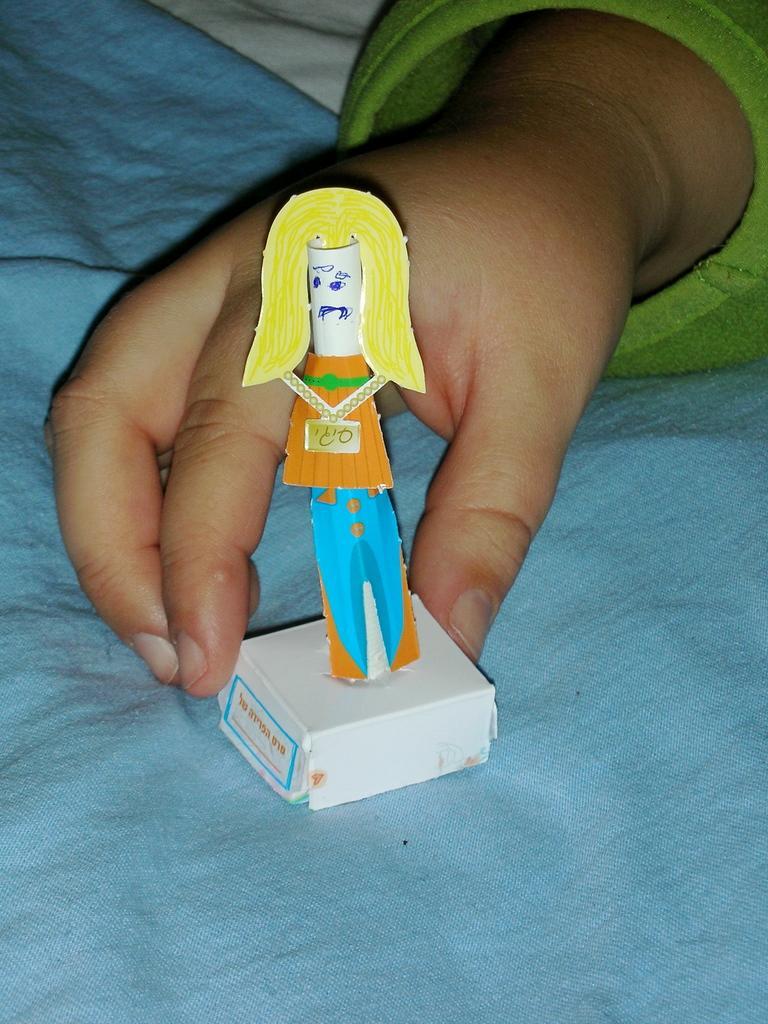Describe this image in one or two sentences. In the image there is a person hand holding a toy. And there is a blue color cloth. 